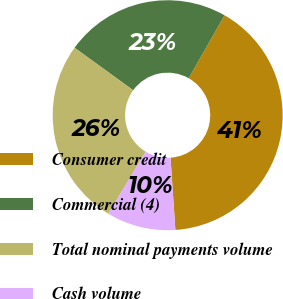<chart> <loc_0><loc_0><loc_500><loc_500><pie_chart><fcel>Consumer credit<fcel>Commercial (4)<fcel>Total nominal payments volume<fcel>Cash volume<nl><fcel>40.7%<fcel>23.26%<fcel>26.36%<fcel>9.69%<nl></chart> 